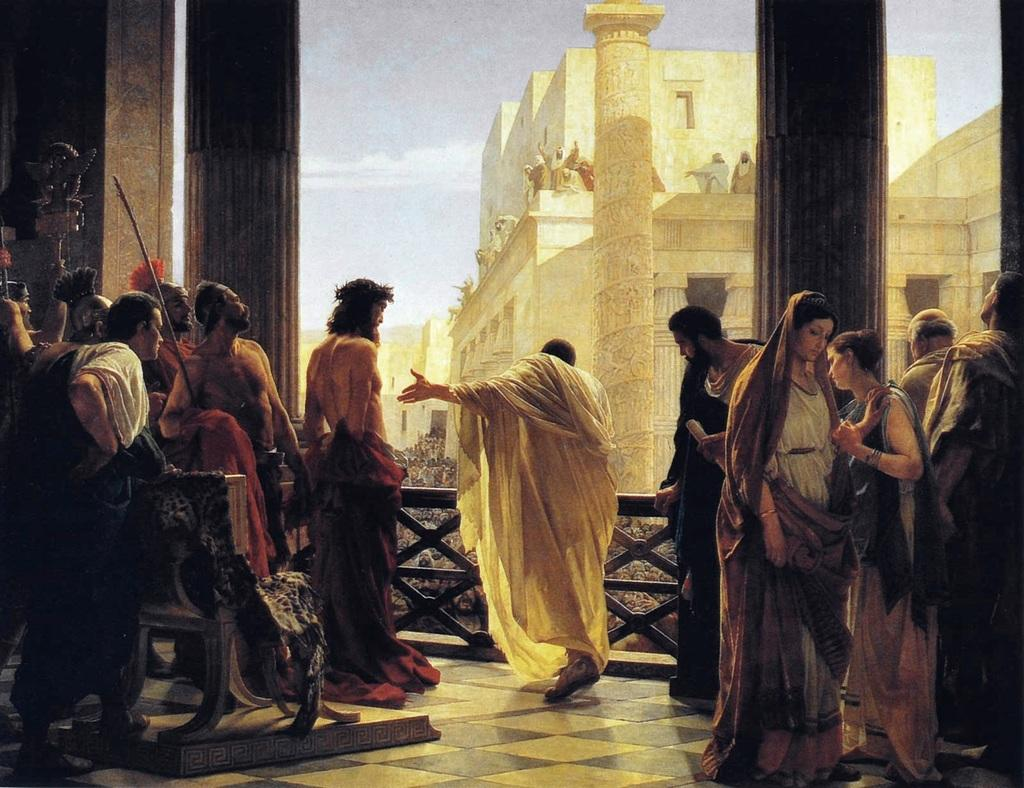What type of artwork is depicted in the image? The image is a painting. What is happening inside the building in the painting? The details of the scene inside the building are not clear from the provided facts, so we cannot answer this question definitively. What can be seen in the background of the painting? There are buildings and the sky visible in the background of the painting. What type of sheet is covering the goose in the painting? There is no goose present in the painting, so there is no sheet covering it. 